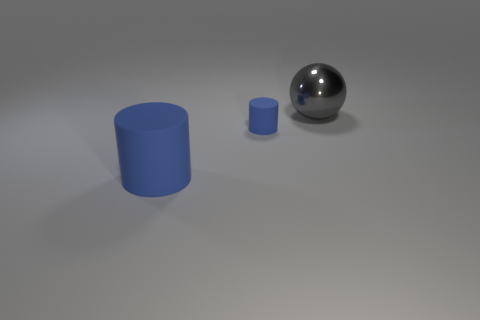Add 3 large blue matte cylinders. How many objects exist? 6 Subtract all spheres. How many objects are left? 2 Add 1 large gray metal things. How many large gray metal things are left? 2 Add 1 tiny rubber objects. How many tiny rubber objects exist? 2 Subtract 0 red cubes. How many objects are left? 3 Subtract all large purple matte blocks. Subtract all large cylinders. How many objects are left? 2 